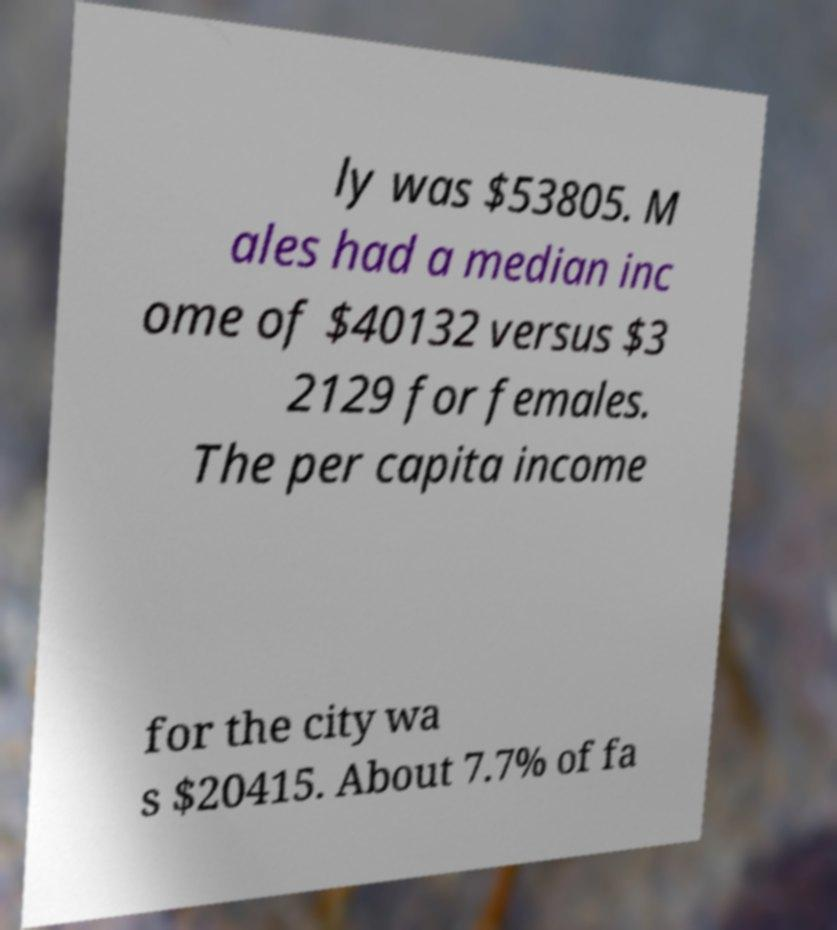There's text embedded in this image that I need extracted. Can you transcribe it verbatim? ly was $53805. M ales had a median inc ome of $40132 versus $3 2129 for females. The per capita income for the city wa s $20415. About 7.7% of fa 